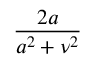<formula> <loc_0><loc_0><loc_500><loc_500>\frac { 2 a } { a ^ { 2 } + \nu ^ { 2 } }</formula> 